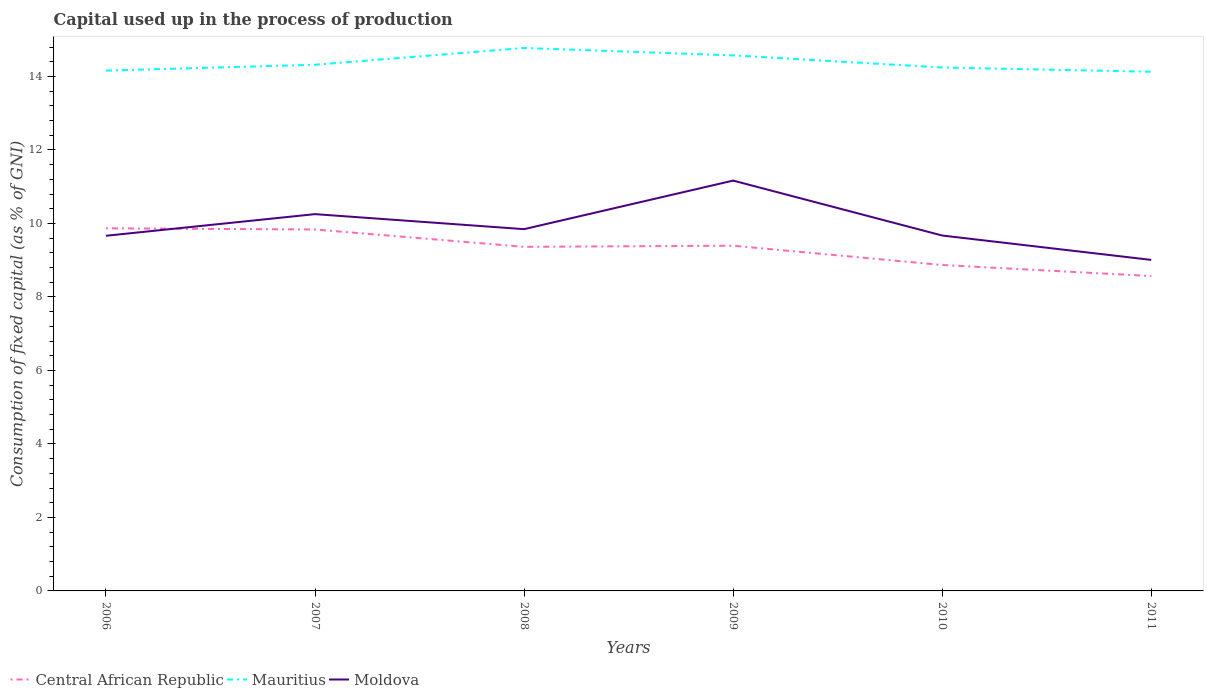How many different coloured lines are there?
Offer a very short reply. 3. Does the line corresponding to Mauritius intersect with the line corresponding to Central African Republic?
Offer a very short reply. No. Is the number of lines equal to the number of legend labels?
Provide a short and direct response. Yes. Across all years, what is the maximum capital used up in the process of production in Mauritius?
Your answer should be very brief. 14.13. In which year was the capital used up in the process of production in Mauritius maximum?
Give a very brief answer. 2011. What is the total capital used up in the process of production in Moldova in the graph?
Offer a very short reply. 0.41. What is the difference between the highest and the second highest capital used up in the process of production in Central African Republic?
Make the answer very short. 1.3. Is the capital used up in the process of production in Mauritius strictly greater than the capital used up in the process of production in Moldova over the years?
Your answer should be very brief. No. How many lines are there?
Provide a succinct answer. 3. Are the values on the major ticks of Y-axis written in scientific E-notation?
Offer a terse response. No. How many legend labels are there?
Your answer should be very brief. 3. How are the legend labels stacked?
Your answer should be compact. Horizontal. What is the title of the graph?
Provide a short and direct response. Capital used up in the process of production. What is the label or title of the X-axis?
Your response must be concise. Years. What is the label or title of the Y-axis?
Make the answer very short. Consumption of fixed capital (as % of GNI). What is the Consumption of fixed capital (as % of GNI) in Central African Republic in 2006?
Keep it short and to the point. 9.87. What is the Consumption of fixed capital (as % of GNI) of Mauritius in 2006?
Your answer should be compact. 14.16. What is the Consumption of fixed capital (as % of GNI) in Moldova in 2006?
Give a very brief answer. 9.66. What is the Consumption of fixed capital (as % of GNI) of Central African Republic in 2007?
Keep it short and to the point. 9.83. What is the Consumption of fixed capital (as % of GNI) of Mauritius in 2007?
Make the answer very short. 14.32. What is the Consumption of fixed capital (as % of GNI) of Moldova in 2007?
Make the answer very short. 10.25. What is the Consumption of fixed capital (as % of GNI) of Central African Republic in 2008?
Offer a very short reply. 9.36. What is the Consumption of fixed capital (as % of GNI) of Mauritius in 2008?
Keep it short and to the point. 14.77. What is the Consumption of fixed capital (as % of GNI) of Moldova in 2008?
Provide a succinct answer. 9.84. What is the Consumption of fixed capital (as % of GNI) of Central African Republic in 2009?
Provide a succinct answer. 9.39. What is the Consumption of fixed capital (as % of GNI) of Mauritius in 2009?
Offer a terse response. 14.57. What is the Consumption of fixed capital (as % of GNI) of Moldova in 2009?
Provide a short and direct response. 11.17. What is the Consumption of fixed capital (as % of GNI) in Central African Republic in 2010?
Keep it short and to the point. 8.87. What is the Consumption of fixed capital (as % of GNI) of Mauritius in 2010?
Your answer should be compact. 14.24. What is the Consumption of fixed capital (as % of GNI) in Moldova in 2010?
Make the answer very short. 9.67. What is the Consumption of fixed capital (as % of GNI) in Central African Republic in 2011?
Offer a terse response. 8.57. What is the Consumption of fixed capital (as % of GNI) in Mauritius in 2011?
Your answer should be compact. 14.13. What is the Consumption of fixed capital (as % of GNI) of Moldova in 2011?
Keep it short and to the point. 9.01. Across all years, what is the maximum Consumption of fixed capital (as % of GNI) of Central African Republic?
Keep it short and to the point. 9.87. Across all years, what is the maximum Consumption of fixed capital (as % of GNI) in Mauritius?
Offer a very short reply. 14.77. Across all years, what is the maximum Consumption of fixed capital (as % of GNI) in Moldova?
Your answer should be very brief. 11.17. Across all years, what is the minimum Consumption of fixed capital (as % of GNI) in Central African Republic?
Keep it short and to the point. 8.57. Across all years, what is the minimum Consumption of fixed capital (as % of GNI) of Mauritius?
Keep it short and to the point. 14.13. Across all years, what is the minimum Consumption of fixed capital (as % of GNI) of Moldova?
Ensure brevity in your answer.  9.01. What is the total Consumption of fixed capital (as % of GNI) in Central African Republic in the graph?
Give a very brief answer. 55.89. What is the total Consumption of fixed capital (as % of GNI) in Mauritius in the graph?
Ensure brevity in your answer.  86.19. What is the total Consumption of fixed capital (as % of GNI) of Moldova in the graph?
Offer a terse response. 59.6. What is the difference between the Consumption of fixed capital (as % of GNI) in Central African Republic in 2006 and that in 2007?
Your answer should be very brief. 0.03. What is the difference between the Consumption of fixed capital (as % of GNI) in Mauritius in 2006 and that in 2007?
Keep it short and to the point. -0.16. What is the difference between the Consumption of fixed capital (as % of GNI) of Moldova in 2006 and that in 2007?
Make the answer very short. -0.59. What is the difference between the Consumption of fixed capital (as % of GNI) in Central African Republic in 2006 and that in 2008?
Offer a very short reply. 0.5. What is the difference between the Consumption of fixed capital (as % of GNI) in Mauritius in 2006 and that in 2008?
Provide a succinct answer. -0.62. What is the difference between the Consumption of fixed capital (as % of GNI) of Moldova in 2006 and that in 2008?
Offer a terse response. -0.18. What is the difference between the Consumption of fixed capital (as % of GNI) of Central African Republic in 2006 and that in 2009?
Provide a short and direct response. 0.47. What is the difference between the Consumption of fixed capital (as % of GNI) in Mauritius in 2006 and that in 2009?
Offer a terse response. -0.41. What is the difference between the Consumption of fixed capital (as % of GNI) of Moldova in 2006 and that in 2009?
Your response must be concise. -1.5. What is the difference between the Consumption of fixed capital (as % of GNI) of Mauritius in 2006 and that in 2010?
Your response must be concise. -0.08. What is the difference between the Consumption of fixed capital (as % of GNI) of Moldova in 2006 and that in 2010?
Provide a succinct answer. -0.01. What is the difference between the Consumption of fixed capital (as % of GNI) of Central African Republic in 2006 and that in 2011?
Your answer should be compact. 1.3. What is the difference between the Consumption of fixed capital (as % of GNI) in Mauritius in 2006 and that in 2011?
Your answer should be very brief. 0.03. What is the difference between the Consumption of fixed capital (as % of GNI) of Moldova in 2006 and that in 2011?
Offer a very short reply. 0.66. What is the difference between the Consumption of fixed capital (as % of GNI) in Central African Republic in 2007 and that in 2008?
Give a very brief answer. 0.47. What is the difference between the Consumption of fixed capital (as % of GNI) of Mauritius in 2007 and that in 2008?
Your answer should be compact. -0.46. What is the difference between the Consumption of fixed capital (as % of GNI) of Moldova in 2007 and that in 2008?
Keep it short and to the point. 0.41. What is the difference between the Consumption of fixed capital (as % of GNI) in Central African Republic in 2007 and that in 2009?
Ensure brevity in your answer.  0.44. What is the difference between the Consumption of fixed capital (as % of GNI) in Mauritius in 2007 and that in 2009?
Keep it short and to the point. -0.25. What is the difference between the Consumption of fixed capital (as % of GNI) of Moldova in 2007 and that in 2009?
Provide a succinct answer. -0.91. What is the difference between the Consumption of fixed capital (as % of GNI) in Central African Republic in 2007 and that in 2010?
Offer a very short reply. 0.97. What is the difference between the Consumption of fixed capital (as % of GNI) in Mauritius in 2007 and that in 2010?
Ensure brevity in your answer.  0.07. What is the difference between the Consumption of fixed capital (as % of GNI) in Moldova in 2007 and that in 2010?
Offer a very short reply. 0.58. What is the difference between the Consumption of fixed capital (as % of GNI) in Central African Republic in 2007 and that in 2011?
Keep it short and to the point. 1.27. What is the difference between the Consumption of fixed capital (as % of GNI) of Mauritius in 2007 and that in 2011?
Provide a short and direct response. 0.19. What is the difference between the Consumption of fixed capital (as % of GNI) in Moldova in 2007 and that in 2011?
Your answer should be very brief. 1.25. What is the difference between the Consumption of fixed capital (as % of GNI) in Central African Republic in 2008 and that in 2009?
Provide a succinct answer. -0.03. What is the difference between the Consumption of fixed capital (as % of GNI) in Mauritius in 2008 and that in 2009?
Ensure brevity in your answer.  0.2. What is the difference between the Consumption of fixed capital (as % of GNI) of Moldova in 2008 and that in 2009?
Provide a short and direct response. -1.32. What is the difference between the Consumption of fixed capital (as % of GNI) in Central African Republic in 2008 and that in 2010?
Offer a terse response. 0.49. What is the difference between the Consumption of fixed capital (as % of GNI) in Mauritius in 2008 and that in 2010?
Your response must be concise. 0.53. What is the difference between the Consumption of fixed capital (as % of GNI) in Moldova in 2008 and that in 2010?
Provide a short and direct response. 0.17. What is the difference between the Consumption of fixed capital (as % of GNI) of Central African Republic in 2008 and that in 2011?
Offer a terse response. 0.79. What is the difference between the Consumption of fixed capital (as % of GNI) in Mauritius in 2008 and that in 2011?
Make the answer very short. 0.65. What is the difference between the Consumption of fixed capital (as % of GNI) of Moldova in 2008 and that in 2011?
Ensure brevity in your answer.  0.84. What is the difference between the Consumption of fixed capital (as % of GNI) in Central African Republic in 2009 and that in 2010?
Your response must be concise. 0.52. What is the difference between the Consumption of fixed capital (as % of GNI) of Mauritius in 2009 and that in 2010?
Your answer should be compact. 0.33. What is the difference between the Consumption of fixed capital (as % of GNI) in Moldova in 2009 and that in 2010?
Provide a short and direct response. 1.49. What is the difference between the Consumption of fixed capital (as % of GNI) of Central African Republic in 2009 and that in 2011?
Your answer should be compact. 0.83. What is the difference between the Consumption of fixed capital (as % of GNI) of Mauritius in 2009 and that in 2011?
Your answer should be very brief. 0.45. What is the difference between the Consumption of fixed capital (as % of GNI) in Moldova in 2009 and that in 2011?
Provide a succinct answer. 2.16. What is the difference between the Consumption of fixed capital (as % of GNI) in Central African Republic in 2010 and that in 2011?
Give a very brief answer. 0.3. What is the difference between the Consumption of fixed capital (as % of GNI) in Mauritius in 2010 and that in 2011?
Give a very brief answer. 0.12. What is the difference between the Consumption of fixed capital (as % of GNI) of Moldova in 2010 and that in 2011?
Ensure brevity in your answer.  0.66. What is the difference between the Consumption of fixed capital (as % of GNI) in Central African Republic in 2006 and the Consumption of fixed capital (as % of GNI) in Mauritius in 2007?
Provide a succinct answer. -4.45. What is the difference between the Consumption of fixed capital (as % of GNI) in Central African Republic in 2006 and the Consumption of fixed capital (as % of GNI) in Moldova in 2007?
Offer a terse response. -0.39. What is the difference between the Consumption of fixed capital (as % of GNI) of Mauritius in 2006 and the Consumption of fixed capital (as % of GNI) of Moldova in 2007?
Your answer should be very brief. 3.91. What is the difference between the Consumption of fixed capital (as % of GNI) in Central African Republic in 2006 and the Consumption of fixed capital (as % of GNI) in Mauritius in 2008?
Your answer should be compact. -4.91. What is the difference between the Consumption of fixed capital (as % of GNI) in Central African Republic in 2006 and the Consumption of fixed capital (as % of GNI) in Moldova in 2008?
Keep it short and to the point. 0.02. What is the difference between the Consumption of fixed capital (as % of GNI) of Mauritius in 2006 and the Consumption of fixed capital (as % of GNI) of Moldova in 2008?
Keep it short and to the point. 4.31. What is the difference between the Consumption of fixed capital (as % of GNI) in Central African Republic in 2006 and the Consumption of fixed capital (as % of GNI) in Mauritius in 2009?
Offer a very short reply. -4.71. What is the difference between the Consumption of fixed capital (as % of GNI) in Central African Republic in 2006 and the Consumption of fixed capital (as % of GNI) in Moldova in 2009?
Offer a terse response. -1.3. What is the difference between the Consumption of fixed capital (as % of GNI) in Mauritius in 2006 and the Consumption of fixed capital (as % of GNI) in Moldova in 2009?
Make the answer very short. 2.99. What is the difference between the Consumption of fixed capital (as % of GNI) in Central African Republic in 2006 and the Consumption of fixed capital (as % of GNI) in Mauritius in 2010?
Ensure brevity in your answer.  -4.38. What is the difference between the Consumption of fixed capital (as % of GNI) of Central African Republic in 2006 and the Consumption of fixed capital (as % of GNI) of Moldova in 2010?
Offer a very short reply. 0.2. What is the difference between the Consumption of fixed capital (as % of GNI) in Mauritius in 2006 and the Consumption of fixed capital (as % of GNI) in Moldova in 2010?
Offer a terse response. 4.49. What is the difference between the Consumption of fixed capital (as % of GNI) of Central African Republic in 2006 and the Consumption of fixed capital (as % of GNI) of Mauritius in 2011?
Your response must be concise. -4.26. What is the difference between the Consumption of fixed capital (as % of GNI) in Central African Republic in 2006 and the Consumption of fixed capital (as % of GNI) in Moldova in 2011?
Make the answer very short. 0.86. What is the difference between the Consumption of fixed capital (as % of GNI) in Mauritius in 2006 and the Consumption of fixed capital (as % of GNI) in Moldova in 2011?
Your response must be concise. 5.15. What is the difference between the Consumption of fixed capital (as % of GNI) in Central African Republic in 2007 and the Consumption of fixed capital (as % of GNI) in Mauritius in 2008?
Give a very brief answer. -4.94. What is the difference between the Consumption of fixed capital (as % of GNI) of Central African Republic in 2007 and the Consumption of fixed capital (as % of GNI) of Moldova in 2008?
Offer a terse response. -0.01. What is the difference between the Consumption of fixed capital (as % of GNI) of Mauritius in 2007 and the Consumption of fixed capital (as % of GNI) of Moldova in 2008?
Ensure brevity in your answer.  4.47. What is the difference between the Consumption of fixed capital (as % of GNI) of Central African Republic in 2007 and the Consumption of fixed capital (as % of GNI) of Mauritius in 2009?
Give a very brief answer. -4.74. What is the difference between the Consumption of fixed capital (as % of GNI) in Central African Republic in 2007 and the Consumption of fixed capital (as % of GNI) in Moldova in 2009?
Your answer should be very brief. -1.33. What is the difference between the Consumption of fixed capital (as % of GNI) of Mauritius in 2007 and the Consumption of fixed capital (as % of GNI) of Moldova in 2009?
Give a very brief answer. 3.15. What is the difference between the Consumption of fixed capital (as % of GNI) in Central African Republic in 2007 and the Consumption of fixed capital (as % of GNI) in Mauritius in 2010?
Ensure brevity in your answer.  -4.41. What is the difference between the Consumption of fixed capital (as % of GNI) of Central African Republic in 2007 and the Consumption of fixed capital (as % of GNI) of Moldova in 2010?
Provide a short and direct response. 0.16. What is the difference between the Consumption of fixed capital (as % of GNI) in Mauritius in 2007 and the Consumption of fixed capital (as % of GNI) in Moldova in 2010?
Keep it short and to the point. 4.65. What is the difference between the Consumption of fixed capital (as % of GNI) in Central African Republic in 2007 and the Consumption of fixed capital (as % of GNI) in Mauritius in 2011?
Offer a very short reply. -4.29. What is the difference between the Consumption of fixed capital (as % of GNI) of Central African Republic in 2007 and the Consumption of fixed capital (as % of GNI) of Moldova in 2011?
Give a very brief answer. 0.83. What is the difference between the Consumption of fixed capital (as % of GNI) in Mauritius in 2007 and the Consumption of fixed capital (as % of GNI) in Moldova in 2011?
Provide a short and direct response. 5.31. What is the difference between the Consumption of fixed capital (as % of GNI) of Central African Republic in 2008 and the Consumption of fixed capital (as % of GNI) of Mauritius in 2009?
Your answer should be compact. -5.21. What is the difference between the Consumption of fixed capital (as % of GNI) in Central African Republic in 2008 and the Consumption of fixed capital (as % of GNI) in Moldova in 2009?
Offer a terse response. -1.8. What is the difference between the Consumption of fixed capital (as % of GNI) of Mauritius in 2008 and the Consumption of fixed capital (as % of GNI) of Moldova in 2009?
Your answer should be very brief. 3.61. What is the difference between the Consumption of fixed capital (as % of GNI) of Central African Republic in 2008 and the Consumption of fixed capital (as % of GNI) of Mauritius in 2010?
Make the answer very short. -4.88. What is the difference between the Consumption of fixed capital (as % of GNI) in Central African Republic in 2008 and the Consumption of fixed capital (as % of GNI) in Moldova in 2010?
Offer a very short reply. -0.31. What is the difference between the Consumption of fixed capital (as % of GNI) in Mauritius in 2008 and the Consumption of fixed capital (as % of GNI) in Moldova in 2010?
Ensure brevity in your answer.  5.1. What is the difference between the Consumption of fixed capital (as % of GNI) of Central African Republic in 2008 and the Consumption of fixed capital (as % of GNI) of Mauritius in 2011?
Provide a short and direct response. -4.76. What is the difference between the Consumption of fixed capital (as % of GNI) in Central African Republic in 2008 and the Consumption of fixed capital (as % of GNI) in Moldova in 2011?
Your response must be concise. 0.36. What is the difference between the Consumption of fixed capital (as % of GNI) of Mauritius in 2008 and the Consumption of fixed capital (as % of GNI) of Moldova in 2011?
Your answer should be very brief. 5.77. What is the difference between the Consumption of fixed capital (as % of GNI) of Central African Republic in 2009 and the Consumption of fixed capital (as % of GNI) of Mauritius in 2010?
Your answer should be very brief. -4.85. What is the difference between the Consumption of fixed capital (as % of GNI) of Central African Republic in 2009 and the Consumption of fixed capital (as % of GNI) of Moldova in 2010?
Offer a very short reply. -0.28. What is the difference between the Consumption of fixed capital (as % of GNI) in Mauritius in 2009 and the Consumption of fixed capital (as % of GNI) in Moldova in 2010?
Your answer should be very brief. 4.9. What is the difference between the Consumption of fixed capital (as % of GNI) in Central African Republic in 2009 and the Consumption of fixed capital (as % of GNI) in Mauritius in 2011?
Keep it short and to the point. -4.73. What is the difference between the Consumption of fixed capital (as % of GNI) of Central African Republic in 2009 and the Consumption of fixed capital (as % of GNI) of Moldova in 2011?
Your response must be concise. 0.39. What is the difference between the Consumption of fixed capital (as % of GNI) of Mauritius in 2009 and the Consumption of fixed capital (as % of GNI) of Moldova in 2011?
Give a very brief answer. 5.56. What is the difference between the Consumption of fixed capital (as % of GNI) of Central African Republic in 2010 and the Consumption of fixed capital (as % of GNI) of Mauritius in 2011?
Your response must be concise. -5.26. What is the difference between the Consumption of fixed capital (as % of GNI) in Central African Republic in 2010 and the Consumption of fixed capital (as % of GNI) in Moldova in 2011?
Offer a very short reply. -0.14. What is the difference between the Consumption of fixed capital (as % of GNI) in Mauritius in 2010 and the Consumption of fixed capital (as % of GNI) in Moldova in 2011?
Ensure brevity in your answer.  5.24. What is the average Consumption of fixed capital (as % of GNI) in Central African Republic per year?
Offer a terse response. 9.32. What is the average Consumption of fixed capital (as % of GNI) in Mauritius per year?
Provide a short and direct response. 14.37. What is the average Consumption of fixed capital (as % of GNI) of Moldova per year?
Offer a terse response. 9.93. In the year 2006, what is the difference between the Consumption of fixed capital (as % of GNI) in Central African Republic and Consumption of fixed capital (as % of GNI) in Mauritius?
Offer a terse response. -4.29. In the year 2006, what is the difference between the Consumption of fixed capital (as % of GNI) of Central African Republic and Consumption of fixed capital (as % of GNI) of Moldova?
Make the answer very short. 0.2. In the year 2006, what is the difference between the Consumption of fixed capital (as % of GNI) of Mauritius and Consumption of fixed capital (as % of GNI) of Moldova?
Your response must be concise. 4.49. In the year 2007, what is the difference between the Consumption of fixed capital (as % of GNI) of Central African Republic and Consumption of fixed capital (as % of GNI) of Mauritius?
Provide a succinct answer. -4.48. In the year 2007, what is the difference between the Consumption of fixed capital (as % of GNI) in Central African Republic and Consumption of fixed capital (as % of GNI) in Moldova?
Keep it short and to the point. -0.42. In the year 2007, what is the difference between the Consumption of fixed capital (as % of GNI) of Mauritius and Consumption of fixed capital (as % of GNI) of Moldova?
Provide a succinct answer. 4.06. In the year 2008, what is the difference between the Consumption of fixed capital (as % of GNI) in Central African Republic and Consumption of fixed capital (as % of GNI) in Mauritius?
Your answer should be compact. -5.41. In the year 2008, what is the difference between the Consumption of fixed capital (as % of GNI) in Central African Republic and Consumption of fixed capital (as % of GNI) in Moldova?
Your answer should be compact. -0.48. In the year 2008, what is the difference between the Consumption of fixed capital (as % of GNI) in Mauritius and Consumption of fixed capital (as % of GNI) in Moldova?
Provide a succinct answer. 4.93. In the year 2009, what is the difference between the Consumption of fixed capital (as % of GNI) of Central African Republic and Consumption of fixed capital (as % of GNI) of Mauritius?
Ensure brevity in your answer.  -5.18. In the year 2009, what is the difference between the Consumption of fixed capital (as % of GNI) in Central African Republic and Consumption of fixed capital (as % of GNI) in Moldova?
Your answer should be compact. -1.77. In the year 2009, what is the difference between the Consumption of fixed capital (as % of GNI) of Mauritius and Consumption of fixed capital (as % of GNI) of Moldova?
Your answer should be very brief. 3.41. In the year 2010, what is the difference between the Consumption of fixed capital (as % of GNI) of Central African Republic and Consumption of fixed capital (as % of GNI) of Mauritius?
Keep it short and to the point. -5.37. In the year 2010, what is the difference between the Consumption of fixed capital (as % of GNI) in Central African Republic and Consumption of fixed capital (as % of GNI) in Moldova?
Provide a succinct answer. -0.8. In the year 2010, what is the difference between the Consumption of fixed capital (as % of GNI) of Mauritius and Consumption of fixed capital (as % of GNI) of Moldova?
Offer a very short reply. 4.57. In the year 2011, what is the difference between the Consumption of fixed capital (as % of GNI) of Central African Republic and Consumption of fixed capital (as % of GNI) of Mauritius?
Give a very brief answer. -5.56. In the year 2011, what is the difference between the Consumption of fixed capital (as % of GNI) of Central African Republic and Consumption of fixed capital (as % of GNI) of Moldova?
Your response must be concise. -0.44. In the year 2011, what is the difference between the Consumption of fixed capital (as % of GNI) of Mauritius and Consumption of fixed capital (as % of GNI) of Moldova?
Your response must be concise. 5.12. What is the ratio of the Consumption of fixed capital (as % of GNI) of Mauritius in 2006 to that in 2007?
Provide a succinct answer. 0.99. What is the ratio of the Consumption of fixed capital (as % of GNI) of Moldova in 2006 to that in 2007?
Your answer should be compact. 0.94. What is the ratio of the Consumption of fixed capital (as % of GNI) of Central African Republic in 2006 to that in 2008?
Provide a succinct answer. 1.05. What is the ratio of the Consumption of fixed capital (as % of GNI) in Mauritius in 2006 to that in 2008?
Provide a succinct answer. 0.96. What is the ratio of the Consumption of fixed capital (as % of GNI) in Moldova in 2006 to that in 2008?
Give a very brief answer. 0.98. What is the ratio of the Consumption of fixed capital (as % of GNI) in Central African Republic in 2006 to that in 2009?
Your answer should be very brief. 1.05. What is the ratio of the Consumption of fixed capital (as % of GNI) in Mauritius in 2006 to that in 2009?
Provide a short and direct response. 0.97. What is the ratio of the Consumption of fixed capital (as % of GNI) of Moldova in 2006 to that in 2009?
Offer a terse response. 0.87. What is the ratio of the Consumption of fixed capital (as % of GNI) in Central African Republic in 2006 to that in 2010?
Provide a short and direct response. 1.11. What is the ratio of the Consumption of fixed capital (as % of GNI) of Mauritius in 2006 to that in 2010?
Your answer should be compact. 0.99. What is the ratio of the Consumption of fixed capital (as % of GNI) in Moldova in 2006 to that in 2010?
Offer a terse response. 1. What is the ratio of the Consumption of fixed capital (as % of GNI) of Central African Republic in 2006 to that in 2011?
Give a very brief answer. 1.15. What is the ratio of the Consumption of fixed capital (as % of GNI) of Moldova in 2006 to that in 2011?
Your answer should be compact. 1.07. What is the ratio of the Consumption of fixed capital (as % of GNI) in Central African Republic in 2007 to that in 2008?
Ensure brevity in your answer.  1.05. What is the ratio of the Consumption of fixed capital (as % of GNI) of Mauritius in 2007 to that in 2008?
Your answer should be compact. 0.97. What is the ratio of the Consumption of fixed capital (as % of GNI) of Moldova in 2007 to that in 2008?
Your response must be concise. 1.04. What is the ratio of the Consumption of fixed capital (as % of GNI) in Central African Republic in 2007 to that in 2009?
Offer a very short reply. 1.05. What is the ratio of the Consumption of fixed capital (as % of GNI) of Mauritius in 2007 to that in 2009?
Offer a terse response. 0.98. What is the ratio of the Consumption of fixed capital (as % of GNI) of Moldova in 2007 to that in 2009?
Keep it short and to the point. 0.92. What is the ratio of the Consumption of fixed capital (as % of GNI) in Central African Republic in 2007 to that in 2010?
Your response must be concise. 1.11. What is the ratio of the Consumption of fixed capital (as % of GNI) in Mauritius in 2007 to that in 2010?
Ensure brevity in your answer.  1.01. What is the ratio of the Consumption of fixed capital (as % of GNI) in Moldova in 2007 to that in 2010?
Make the answer very short. 1.06. What is the ratio of the Consumption of fixed capital (as % of GNI) of Central African Republic in 2007 to that in 2011?
Make the answer very short. 1.15. What is the ratio of the Consumption of fixed capital (as % of GNI) of Mauritius in 2007 to that in 2011?
Give a very brief answer. 1.01. What is the ratio of the Consumption of fixed capital (as % of GNI) of Moldova in 2007 to that in 2011?
Your response must be concise. 1.14. What is the ratio of the Consumption of fixed capital (as % of GNI) of Central African Republic in 2008 to that in 2009?
Give a very brief answer. 1. What is the ratio of the Consumption of fixed capital (as % of GNI) of Mauritius in 2008 to that in 2009?
Offer a terse response. 1.01. What is the ratio of the Consumption of fixed capital (as % of GNI) of Moldova in 2008 to that in 2009?
Offer a terse response. 0.88. What is the ratio of the Consumption of fixed capital (as % of GNI) in Central African Republic in 2008 to that in 2010?
Give a very brief answer. 1.06. What is the ratio of the Consumption of fixed capital (as % of GNI) of Mauritius in 2008 to that in 2010?
Ensure brevity in your answer.  1.04. What is the ratio of the Consumption of fixed capital (as % of GNI) in Moldova in 2008 to that in 2010?
Offer a very short reply. 1.02. What is the ratio of the Consumption of fixed capital (as % of GNI) in Central African Republic in 2008 to that in 2011?
Ensure brevity in your answer.  1.09. What is the ratio of the Consumption of fixed capital (as % of GNI) of Mauritius in 2008 to that in 2011?
Make the answer very short. 1.05. What is the ratio of the Consumption of fixed capital (as % of GNI) of Moldova in 2008 to that in 2011?
Offer a terse response. 1.09. What is the ratio of the Consumption of fixed capital (as % of GNI) of Central African Republic in 2009 to that in 2010?
Provide a succinct answer. 1.06. What is the ratio of the Consumption of fixed capital (as % of GNI) in Mauritius in 2009 to that in 2010?
Your answer should be very brief. 1.02. What is the ratio of the Consumption of fixed capital (as % of GNI) in Moldova in 2009 to that in 2010?
Keep it short and to the point. 1.15. What is the ratio of the Consumption of fixed capital (as % of GNI) in Central African Republic in 2009 to that in 2011?
Offer a very short reply. 1.1. What is the ratio of the Consumption of fixed capital (as % of GNI) in Mauritius in 2009 to that in 2011?
Your response must be concise. 1.03. What is the ratio of the Consumption of fixed capital (as % of GNI) of Moldova in 2009 to that in 2011?
Your answer should be compact. 1.24. What is the ratio of the Consumption of fixed capital (as % of GNI) of Central African Republic in 2010 to that in 2011?
Offer a terse response. 1.04. What is the ratio of the Consumption of fixed capital (as % of GNI) of Mauritius in 2010 to that in 2011?
Give a very brief answer. 1.01. What is the ratio of the Consumption of fixed capital (as % of GNI) of Moldova in 2010 to that in 2011?
Offer a terse response. 1.07. What is the difference between the highest and the second highest Consumption of fixed capital (as % of GNI) of Central African Republic?
Offer a very short reply. 0.03. What is the difference between the highest and the second highest Consumption of fixed capital (as % of GNI) of Mauritius?
Offer a very short reply. 0.2. What is the difference between the highest and the second highest Consumption of fixed capital (as % of GNI) in Moldova?
Offer a terse response. 0.91. What is the difference between the highest and the lowest Consumption of fixed capital (as % of GNI) in Central African Republic?
Your answer should be compact. 1.3. What is the difference between the highest and the lowest Consumption of fixed capital (as % of GNI) in Mauritius?
Your answer should be compact. 0.65. What is the difference between the highest and the lowest Consumption of fixed capital (as % of GNI) of Moldova?
Your answer should be very brief. 2.16. 